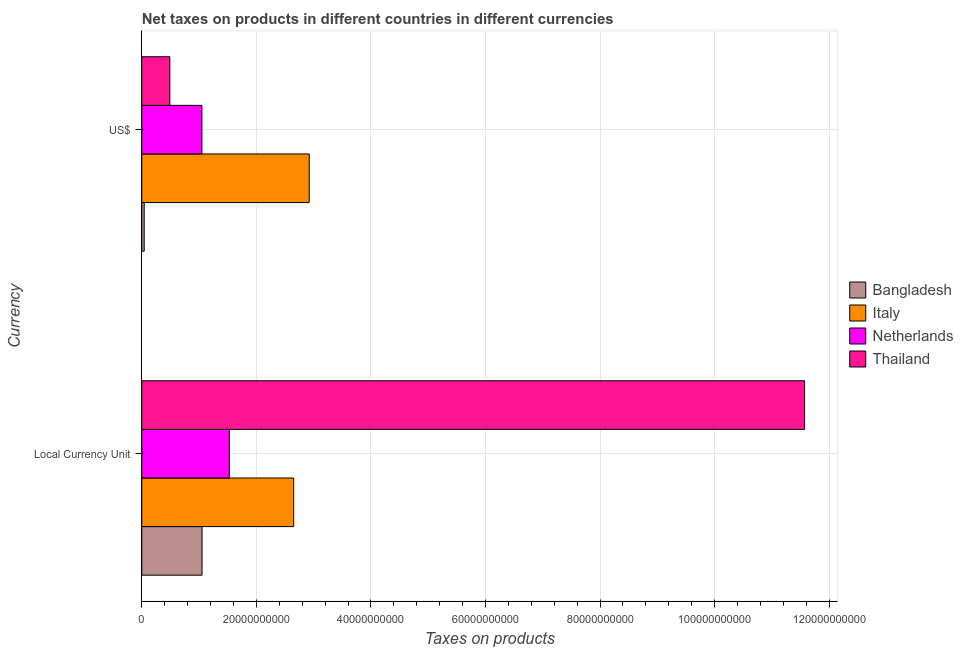How many different coloured bars are there?
Keep it short and to the point. 4. How many groups of bars are there?
Your answer should be very brief. 2. Are the number of bars on each tick of the Y-axis equal?
Give a very brief answer. Yes. How many bars are there on the 2nd tick from the bottom?
Provide a short and direct response. 4. What is the label of the 1st group of bars from the top?
Offer a terse response. US$. What is the net taxes in constant 2005 us$ in Bangladesh?
Ensure brevity in your answer.  1.05e+1. Across all countries, what is the maximum net taxes in us$?
Provide a short and direct response. 2.92e+1. Across all countries, what is the minimum net taxes in constant 2005 us$?
Your response must be concise. 1.05e+1. In which country was the net taxes in constant 2005 us$ maximum?
Provide a succinct answer. Thailand. In which country was the net taxes in us$ minimum?
Your response must be concise. Bangladesh. What is the total net taxes in us$ in the graph?
Give a very brief answer. 4.50e+1. What is the difference between the net taxes in constant 2005 us$ in Bangladesh and that in Netherlands?
Provide a succinct answer. -4.76e+09. What is the difference between the net taxes in constant 2005 us$ in Bangladesh and the net taxes in us$ in Italy?
Your answer should be very brief. -1.87e+1. What is the average net taxes in us$ per country?
Offer a terse response. 1.13e+1. What is the difference between the net taxes in constant 2005 us$ and net taxes in us$ in Bangladesh?
Make the answer very short. 1.01e+1. In how many countries, is the net taxes in us$ greater than 68000000000 units?
Keep it short and to the point. 0. What is the ratio of the net taxes in us$ in Bangladesh to that in Netherlands?
Offer a terse response. 0.04. Is the net taxes in constant 2005 us$ in Netherlands less than that in Thailand?
Offer a very short reply. Yes. What does the 1st bar from the top in US$ represents?
Keep it short and to the point. Thailand. How many bars are there?
Offer a terse response. 8. Are all the bars in the graph horizontal?
Provide a succinct answer. Yes. Does the graph contain any zero values?
Your answer should be compact. No. Does the graph contain grids?
Offer a very short reply. Yes. Where does the legend appear in the graph?
Provide a short and direct response. Center right. How many legend labels are there?
Your response must be concise. 4. What is the title of the graph?
Provide a succinct answer. Net taxes on products in different countries in different currencies. Does "Ireland" appear as one of the legend labels in the graph?
Provide a succinct answer. No. What is the label or title of the X-axis?
Your answer should be compact. Taxes on products. What is the label or title of the Y-axis?
Your answer should be compact. Currency. What is the Taxes on products of Bangladesh in Local Currency Unit?
Provide a short and direct response. 1.05e+1. What is the Taxes on products in Italy in Local Currency Unit?
Provide a succinct answer. 2.65e+1. What is the Taxes on products of Netherlands in Local Currency Unit?
Make the answer very short. 1.53e+1. What is the Taxes on products in Thailand in Local Currency Unit?
Ensure brevity in your answer.  1.16e+11. What is the Taxes on products in Bangladesh in US$?
Give a very brief answer. 4.21e+08. What is the Taxes on products of Italy in US$?
Give a very brief answer. 2.92e+1. What is the Taxes on products in Netherlands in US$?
Keep it short and to the point. 1.05e+1. What is the Taxes on products of Thailand in US$?
Offer a very short reply. 4.90e+09. Across all Currency, what is the maximum Taxes on products in Bangladesh?
Ensure brevity in your answer.  1.05e+1. Across all Currency, what is the maximum Taxes on products in Italy?
Provide a short and direct response. 2.92e+1. Across all Currency, what is the maximum Taxes on products in Netherlands?
Provide a short and direct response. 1.53e+1. Across all Currency, what is the maximum Taxes on products in Thailand?
Your answer should be compact. 1.16e+11. Across all Currency, what is the minimum Taxes on products of Bangladesh?
Provide a succinct answer. 4.21e+08. Across all Currency, what is the minimum Taxes on products of Italy?
Give a very brief answer. 2.65e+1. Across all Currency, what is the minimum Taxes on products of Netherlands?
Provide a short and direct response. 1.05e+1. Across all Currency, what is the minimum Taxes on products of Thailand?
Ensure brevity in your answer.  4.90e+09. What is the total Taxes on products in Bangladesh in the graph?
Make the answer very short. 1.09e+1. What is the total Taxes on products in Italy in the graph?
Give a very brief answer. 5.58e+1. What is the total Taxes on products in Netherlands in the graph?
Provide a short and direct response. 2.58e+1. What is the total Taxes on products in Thailand in the graph?
Your response must be concise. 1.21e+11. What is the difference between the Taxes on products in Bangladesh in Local Currency Unit and that in US$?
Make the answer very short. 1.01e+1. What is the difference between the Taxes on products in Italy in Local Currency Unit and that in US$?
Give a very brief answer. -2.71e+09. What is the difference between the Taxes on products in Netherlands in Local Currency Unit and that in US$?
Your answer should be very brief. 4.79e+09. What is the difference between the Taxes on products of Thailand in Local Currency Unit and that in US$?
Make the answer very short. 1.11e+11. What is the difference between the Taxes on products of Bangladesh in Local Currency Unit and the Taxes on products of Italy in US$?
Offer a very short reply. -1.87e+1. What is the difference between the Taxes on products of Bangladesh in Local Currency Unit and the Taxes on products of Netherlands in US$?
Give a very brief answer. 2.29e+07. What is the difference between the Taxes on products in Bangladesh in Local Currency Unit and the Taxes on products in Thailand in US$?
Your answer should be very brief. 5.62e+09. What is the difference between the Taxes on products in Italy in Local Currency Unit and the Taxes on products in Netherlands in US$?
Provide a succinct answer. 1.60e+1. What is the difference between the Taxes on products of Italy in Local Currency Unit and the Taxes on products of Thailand in US$?
Your response must be concise. 2.16e+1. What is the difference between the Taxes on products of Netherlands in Local Currency Unit and the Taxes on products of Thailand in US$?
Your response must be concise. 1.04e+1. What is the average Taxes on products in Bangladesh per Currency?
Provide a succinct answer. 5.47e+09. What is the average Taxes on products in Italy per Currency?
Offer a very short reply. 2.79e+1. What is the average Taxes on products of Netherlands per Currency?
Offer a very short reply. 1.29e+1. What is the average Taxes on products of Thailand per Currency?
Make the answer very short. 6.03e+1. What is the difference between the Taxes on products in Bangladesh and Taxes on products in Italy in Local Currency Unit?
Give a very brief answer. -1.60e+1. What is the difference between the Taxes on products in Bangladesh and Taxes on products in Netherlands in Local Currency Unit?
Your answer should be compact. -4.76e+09. What is the difference between the Taxes on products of Bangladesh and Taxes on products of Thailand in Local Currency Unit?
Keep it short and to the point. -1.05e+11. What is the difference between the Taxes on products of Italy and Taxes on products of Netherlands in Local Currency Unit?
Ensure brevity in your answer.  1.12e+1. What is the difference between the Taxes on products of Italy and Taxes on products of Thailand in Local Currency Unit?
Your response must be concise. -8.92e+1. What is the difference between the Taxes on products of Netherlands and Taxes on products of Thailand in Local Currency Unit?
Your response must be concise. -1.00e+11. What is the difference between the Taxes on products of Bangladesh and Taxes on products of Italy in US$?
Keep it short and to the point. -2.88e+1. What is the difference between the Taxes on products of Bangladesh and Taxes on products of Netherlands in US$?
Offer a very short reply. -1.01e+1. What is the difference between the Taxes on products of Bangladesh and Taxes on products of Thailand in US$?
Make the answer very short. -4.47e+09. What is the difference between the Taxes on products of Italy and Taxes on products of Netherlands in US$?
Ensure brevity in your answer.  1.87e+1. What is the difference between the Taxes on products in Italy and Taxes on products in Thailand in US$?
Offer a very short reply. 2.43e+1. What is the difference between the Taxes on products of Netherlands and Taxes on products of Thailand in US$?
Give a very brief answer. 5.60e+09. What is the ratio of the Taxes on products in Italy in Local Currency Unit to that in US$?
Offer a terse response. 0.91. What is the ratio of the Taxes on products in Netherlands in Local Currency Unit to that in US$?
Ensure brevity in your answer.  1.46. What is the ratio of the Taxes on products in Thailand in Local Currency Unit to that in US$?
Your answer should be compact. 23.64. What is the difference between the highest and the second highest Taxes on products in Bangladesh?
Ensure brevity in your answer.  1.01e+1. What is the difference between the highest and the second highest Taxes on products of Italy?
Offer a terse response. 2.71e+09. What is the difference between the highest and the second highest Taxes on products of Netherlands?
Offer a terse response. 4.79e+09. What is the difference between the highest and the second highest Taxes on products of Thailand?
Give a very brief answer. 1.11e+11. What is the difference between the highest and the lowest Taxes on products in Bangladesh?
Offer a very short reply. 1.01e+1. What is the difference between the highest and the lowest Taxes on products of Italy?
Give a very brief answer. 2.71e+09. What is the difference between the highest and the lowest Taxes on products in Netherlands?
Keep it short and to the point. 4.79e+09. What is the difference between the highest and the lowest Taxes on products of Thailand?
Give a very brief answer. 1.11e+11. 